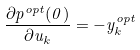Convert formula to latex. <formula><loc_0><loc_0><loc_500><loc_500>\frac { \partial p ^ { o p t } ( 0 ) } { \partial u _ { k } } = - y _ { k } ^ { o p t }</formula> 